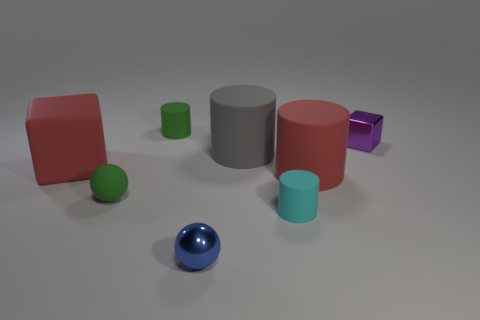There is another small thing that is the same shape as the blue shiny thing; what is its color?
Keep it short and to the point. Green. There is a metallic object left of the small purple cube; is there a matte object that is on the right side of it?
Make the answer very short. Yes. What size is the gray rubber cylinder?
Keep it short and to the point. Large. The thing that is behind the red cube and in front of the purple block has what shape?
Your response must be concise. Cylinder. What number of brown objects are metal balls or shiny objects?
Your answer should be very brief. 0. There is a green matte object behind the shiny block; is it the same size as the sphere behind the blue metal ball?
Make the answer very short. Yes. What number of objects are either big red cubes or large objects?
Give a very brief answer. 3. Are there any green things that have the same shape as the big gray matte object?
Ensure brevity in your answer.  Yes. Is the number of cyan cylinders less than the number of large purple cylinders?
Offer a terse response. No. Is the shape of the gray object the same as the cyan rubber object?
Ensure brevity in your answer.  Yes. 